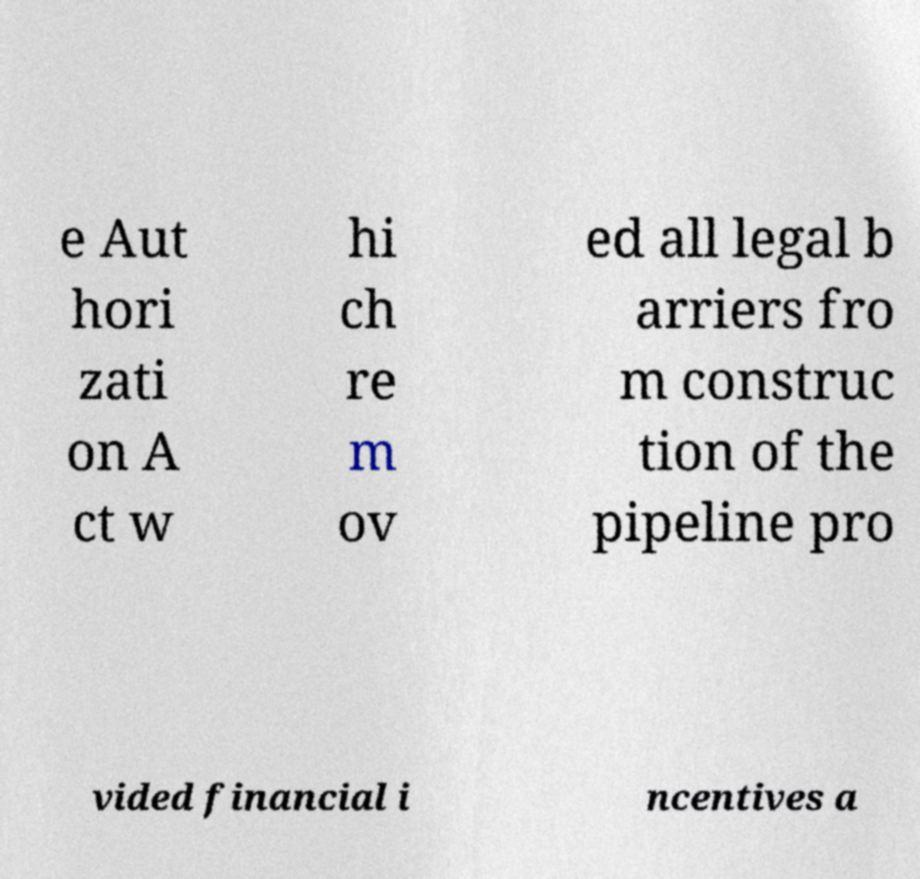What messages or text are displayed in this image? I need them in a readable, typed format. e Aut hori zati on A ct w hi ch re m ov ed all legal b arriers fro m construc tion of the pipeline pro vided financial i ncentives a 